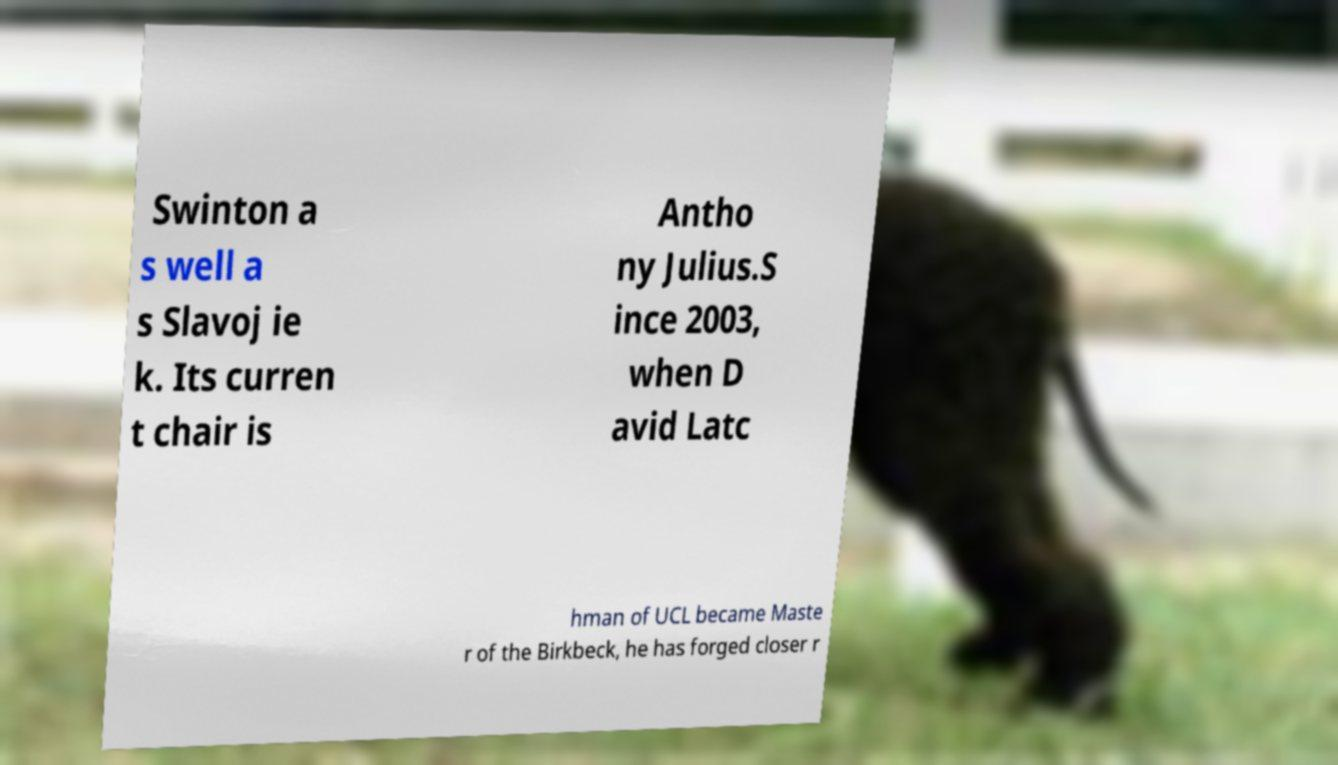I need the written content from this picture converted into text. Can you do that? Swinton a s well a s Slavoj ie k. Its curren t chair is Antho ny Julius.S ince 2003, when D avid Latc hman of UCL became Maste r of the Birkbeck, he has forged closer r 